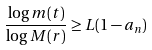Convert formula to latex. <formula><loc_0><loc_0><loc_500><loc_500>\frac { \log m ( t ) } { \log M ( r ) } \geq L ( 1 - a _ { n } )</formula> 